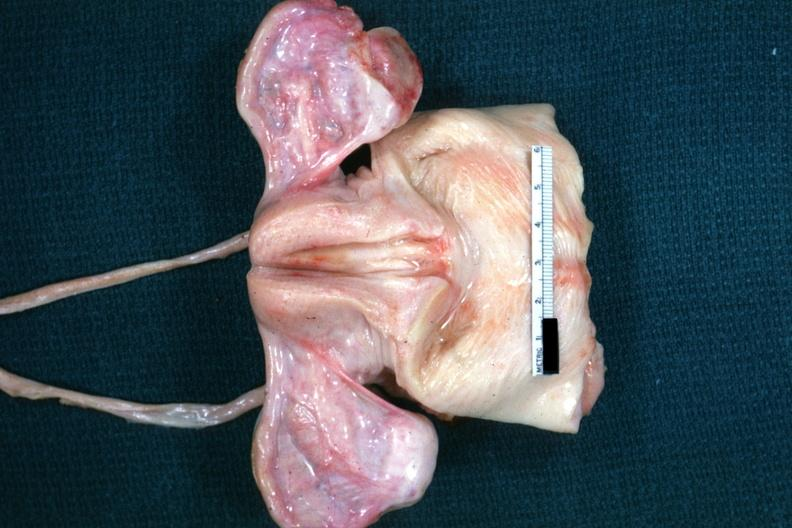what does this image show?
Answer the question using a single word or phrase. Not truly normal ovaries are non functional in case of vacant sella but externally i can see nothing 